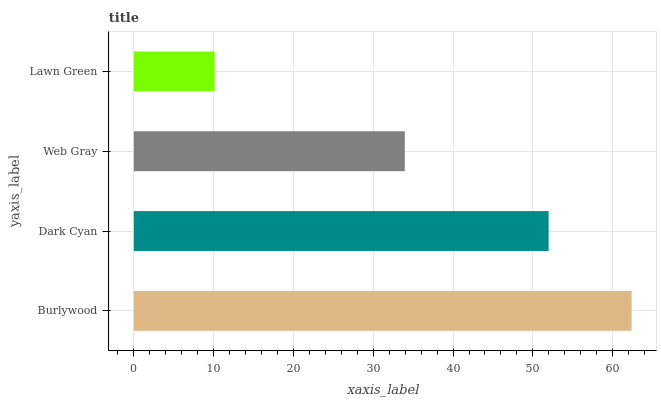Is Lawn Green the minimum?
Answer yes or no. Yes. Is Burlywood the maximum?
Answer yes or no. Yes. Is Dark Cyan the minimum?
Answer yes or no. No. Is Dark Cyan the maximum?
Answer yes or no. No. Is Burlywood greater than Dark Cyan?
Answer yes or no. Yes. Is Dark Cyan less than Burlywood?
Answer yes or no. Yes. Is Dark Cyan greater than Burlywood?
Answer yes or no. No. Is Burlywood less than Dark Cyan?
Answer yes or no. No. Is Dark Cyan the high median?
Answer yes or no. Yes. Is Web Gray the low median?
Answer yes or no. Yes. Is Web Gray the high median?
Answer yes or no. No. Is Dark Cyan the low median?
Answer yes or no. No. 